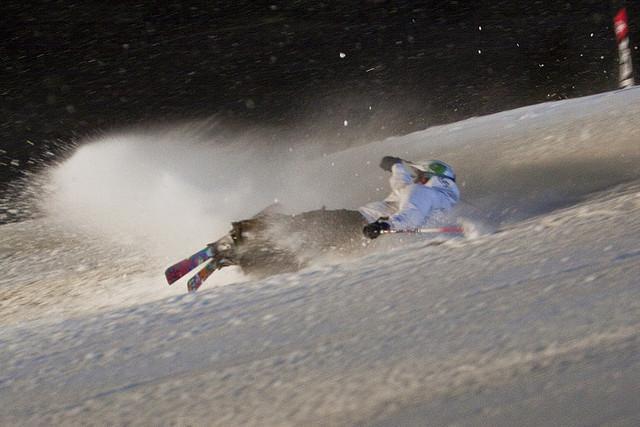How many boats are on the water?
Give a very brief answer. 0. 